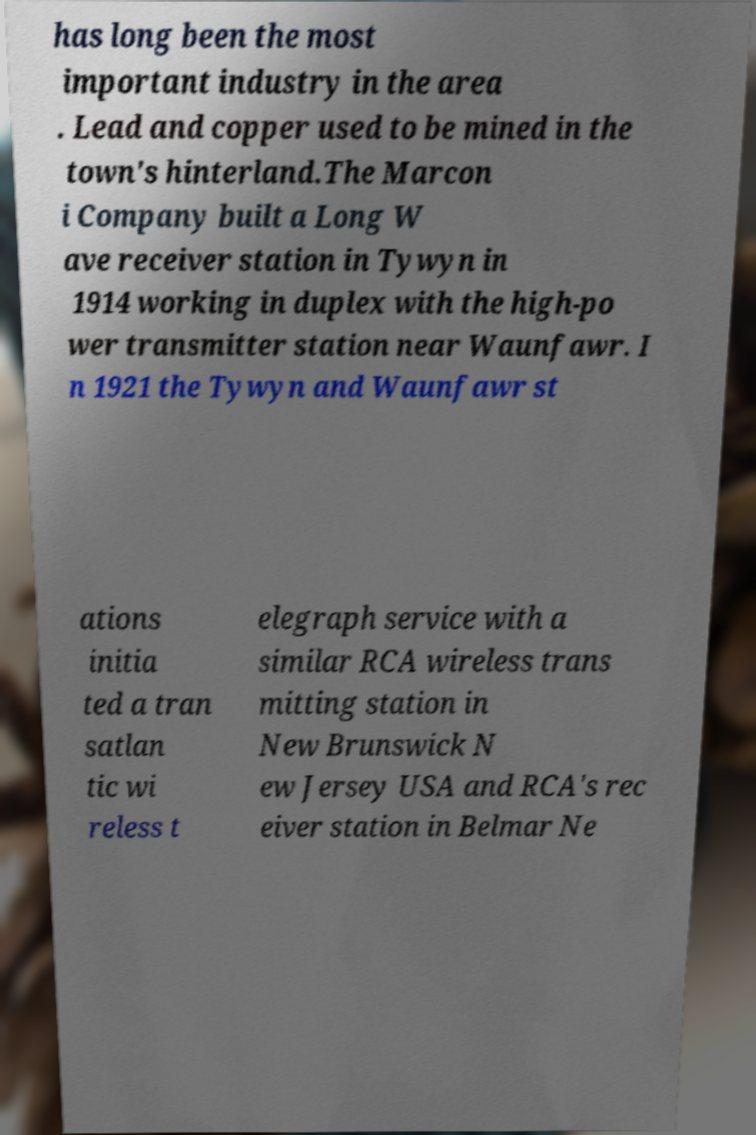I need the written content from this picture converted into text. Can you do that? has long been the most important industry in the area . Lead and copper used to be mined in the town's hinterland.The Marcon i Company built a Long W ave receiver station in Tywyn in 1914 working in duplex with the high-po wer transmitter station near Waunfawr. I n 1921 the Tywyn and Waunfawr st ations initia ted a tran satlan tic wi reless t elegraph service with a similar RCA wireless trans mitting station in New Brunswick N ew Jersey USA and RCA's rec eiver station in Belmar Ne 